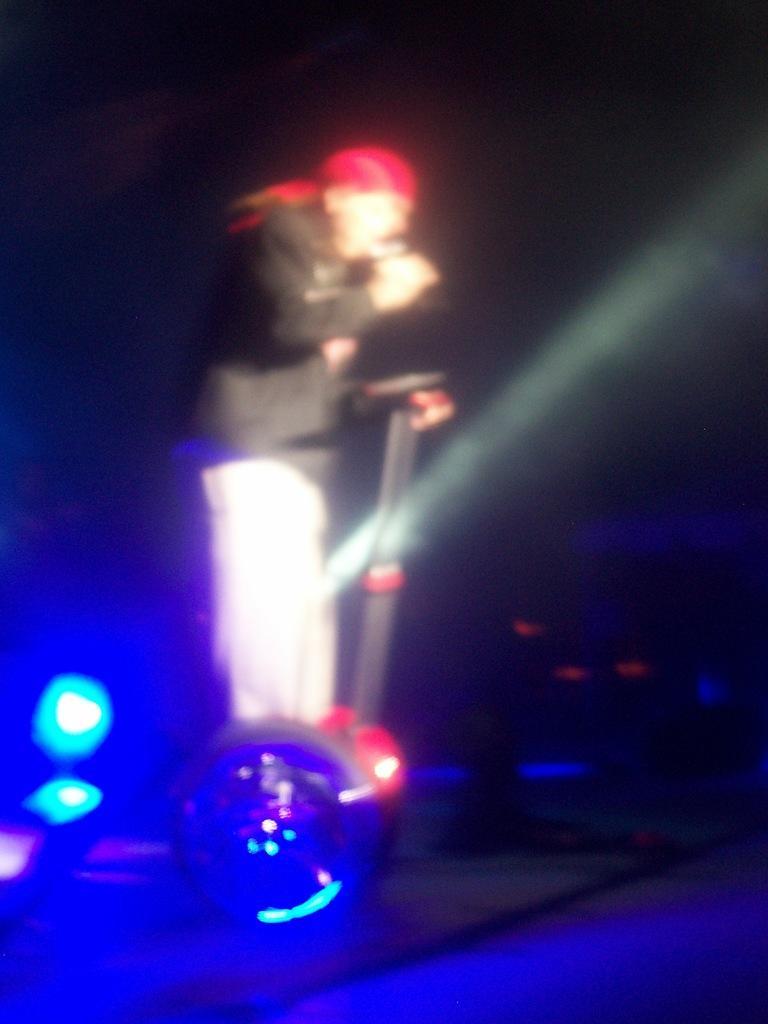Can you describe this image briefly? In this image we can see a person is standing on a platform, lights and other objects. In the background the image is dark. 